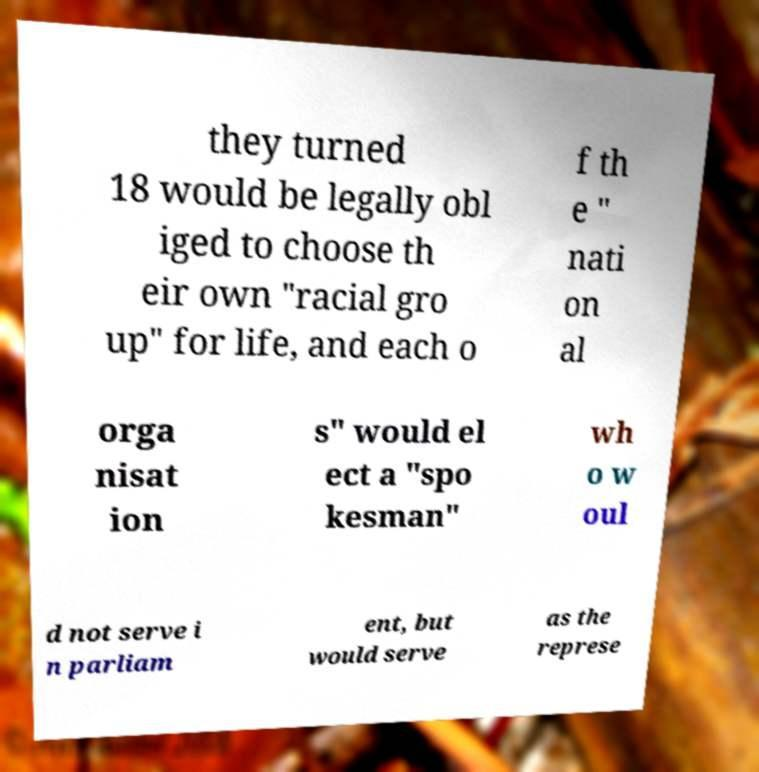There's text embedded in this image that I need extracted. Can you transcribe it verbatim? they turned 18 would be legally obl iged to choose th eir own "racial gro up" for life, and each o f th e " nati on al orga nisat ion s" would el ect a "spo kesman" wh o w oul d not serve i n parliam ent, but would serve as the represe 